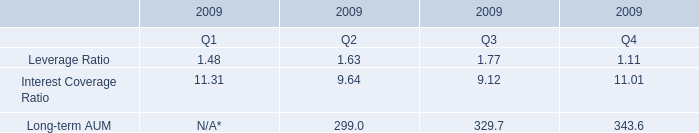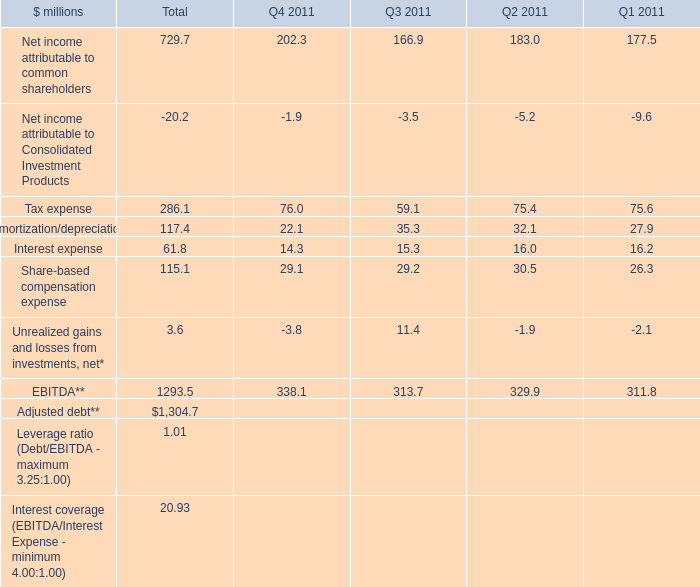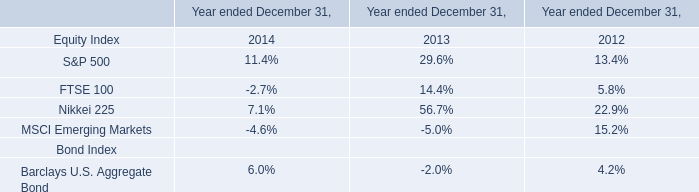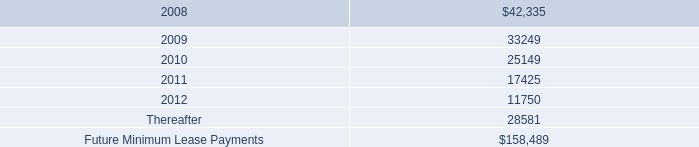How many Interest expense exceed the average of Interest expense in 2011? 
Answer: 2. 